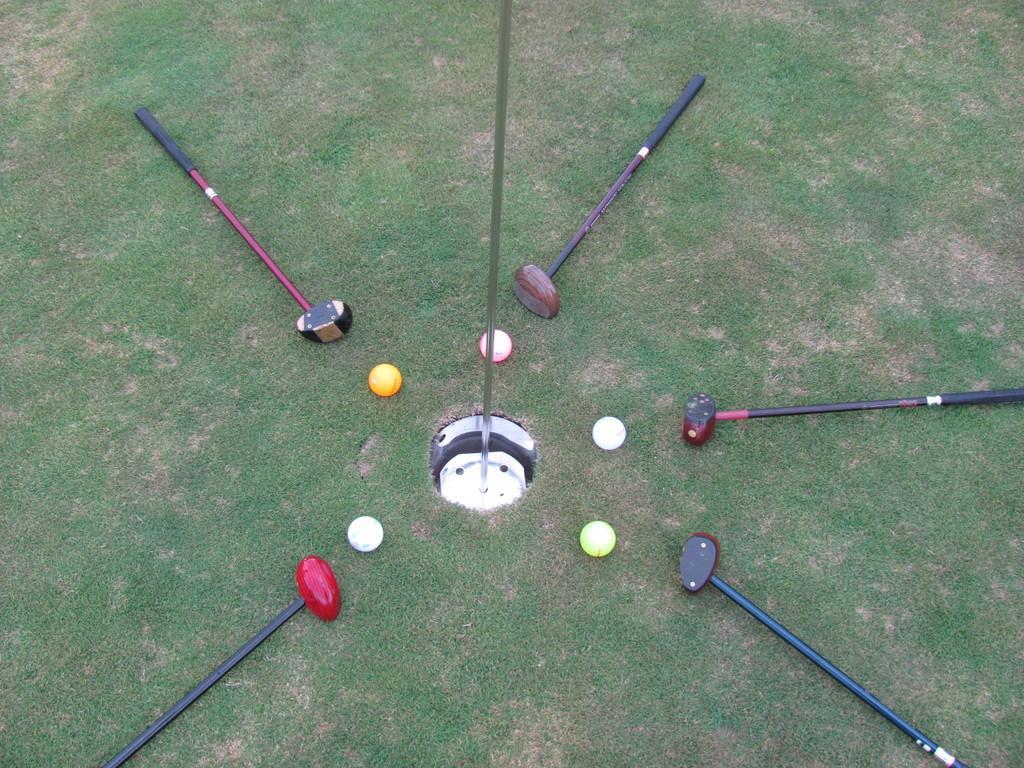Please provide a concise description of this image. In this image there are bats and balls on the grass, in between them there is a iron pole. 